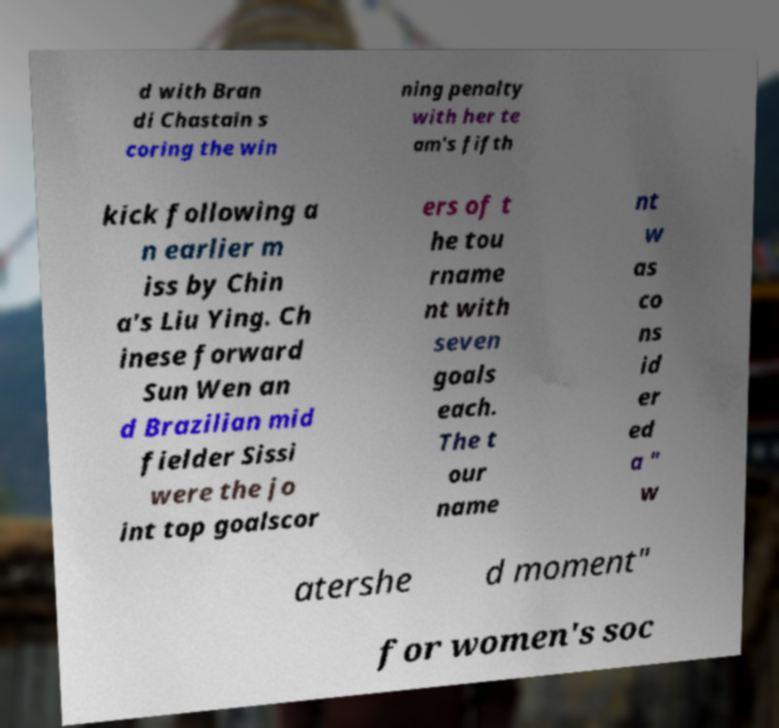Can you read and provide the text displayed in the image?This photo seems to have some interesting text. Can you extract and type it out for me? d with Bran di Chastain s coring the win ning penalty with her te am's fifth kick following a n earlier m iss by Chin a's Liu Ying. Ch inese forward Sun Wen an d Brazilian mid fielder Sissi were the jo int top goalscor ers of t he tou rname nt with seven goals each. The t our name nt w as co ns id er ed a " w atershe d moment" for women's soc 